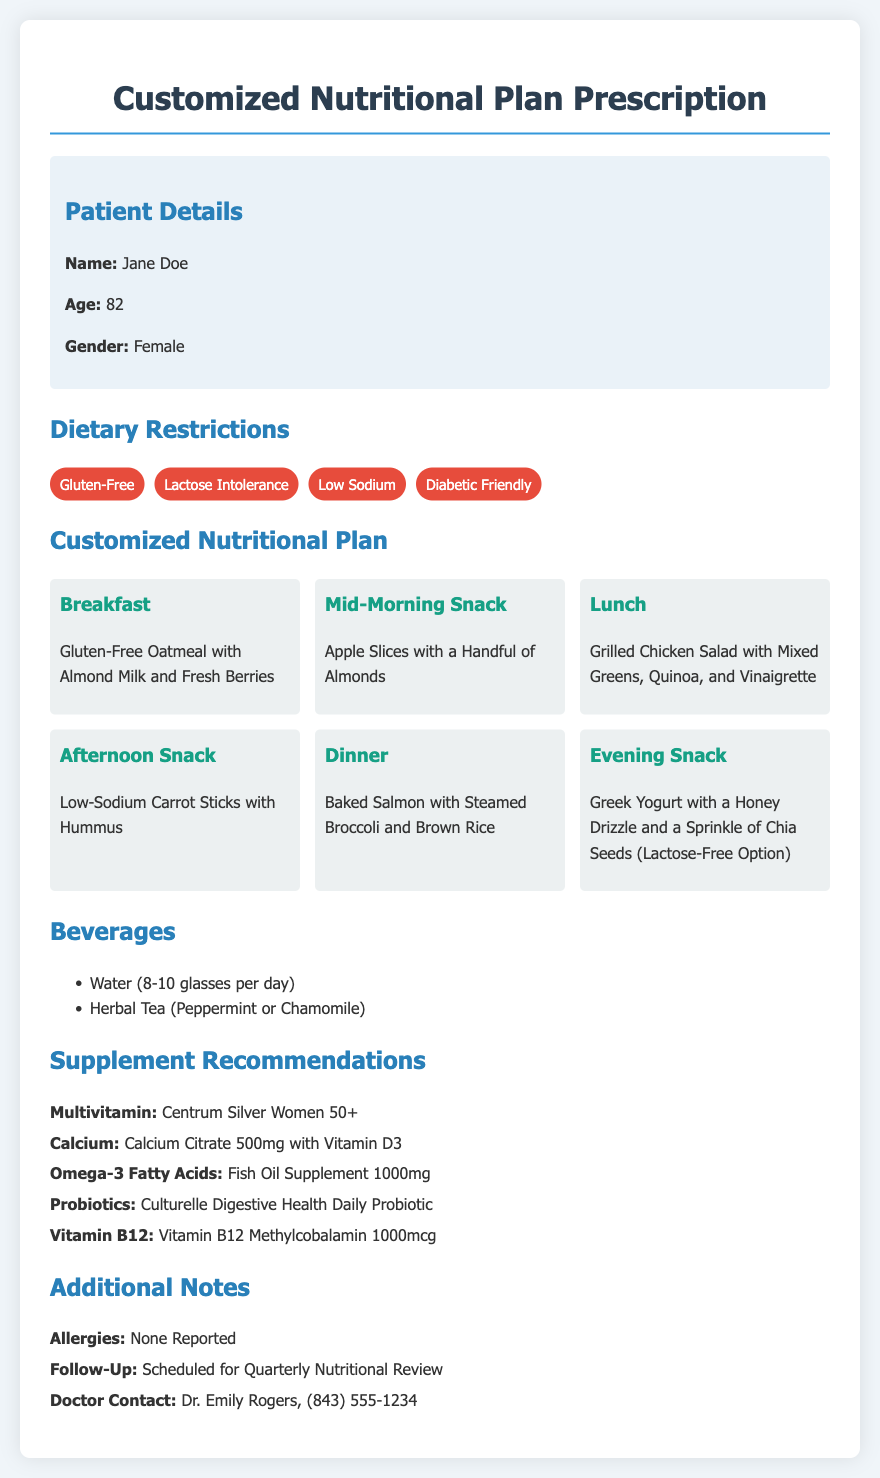What is the patient's name? The patient's name is mentioned in the patient details section.
Answer: Jane Doe How old is the patient? The patient's age is listed in the patient details section.
Answer: 82 What is one dietary restriction? Several dietary restrictions are listed in the dietary restrictions section.
Answer: Gluten-Free What is the recommended beverage? The beverages recommended are listed in the beverages section.
Answer: Water What is for lunch? The lunch meal is specified in the customized nutritional plan section.
Answer: Grilled Chicken Salad with Mixed Greens, Quinoa, and Vinaigrette How many glasses of water should the patient drink daily? The document provides a specific recommendation regarding water intake.
Answer: 8-10 glasses What supplement is recommended for Vitamin D? The supplement recommendations include specific supplements with their purposes.
Answer: Calcium Citrate 500mg with Vitamin D3 When is the follow-up scheduled? The follow-up date is indicated in the additional notes section.
Answer: Quarterly Nutritional Review Who is the doctor associated with the patient's care? The doctor’s information is available in the additional notes section.
Answer: Dr. Emily Rogers 